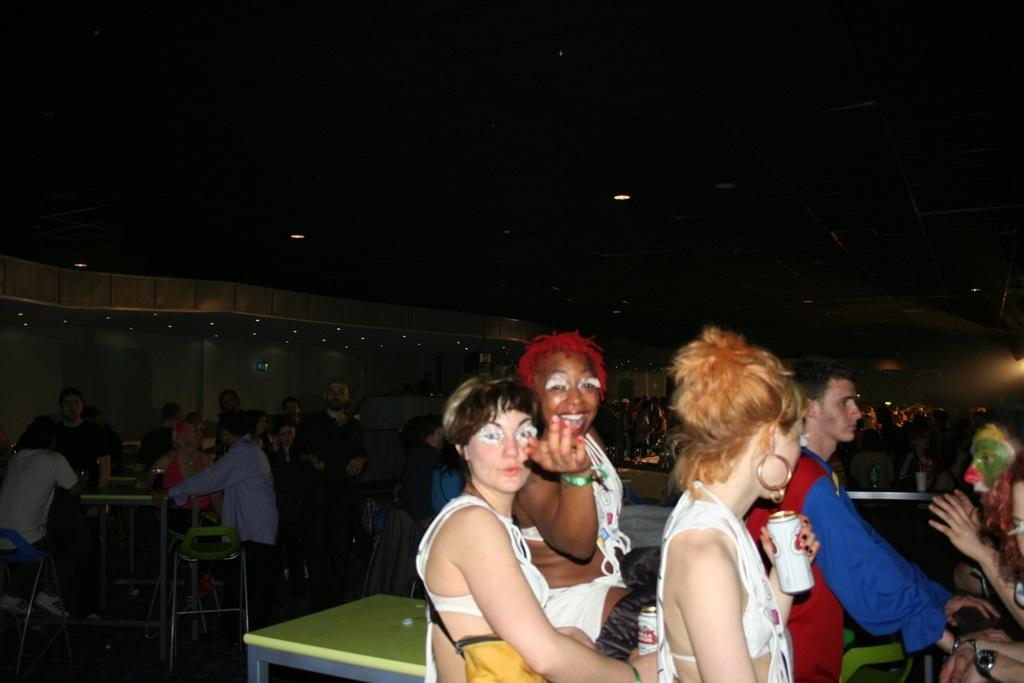How many people are in the image? There is a group of people in the image, but the exact number is not specified. What are the people in the image doing? Some people are sitting, while others are standing. What is the person holding in the image? One person is holding a tin. What is in front of the group in the image? There is a table in front of the group. What type of cannon is being fired in the image? There is no cannon present in the image; it features a group of people with some sitting and standing, one holding a tin, and a table in front of them. What record is being played on the turntable in the image? There is no turntable or record present in the image. 